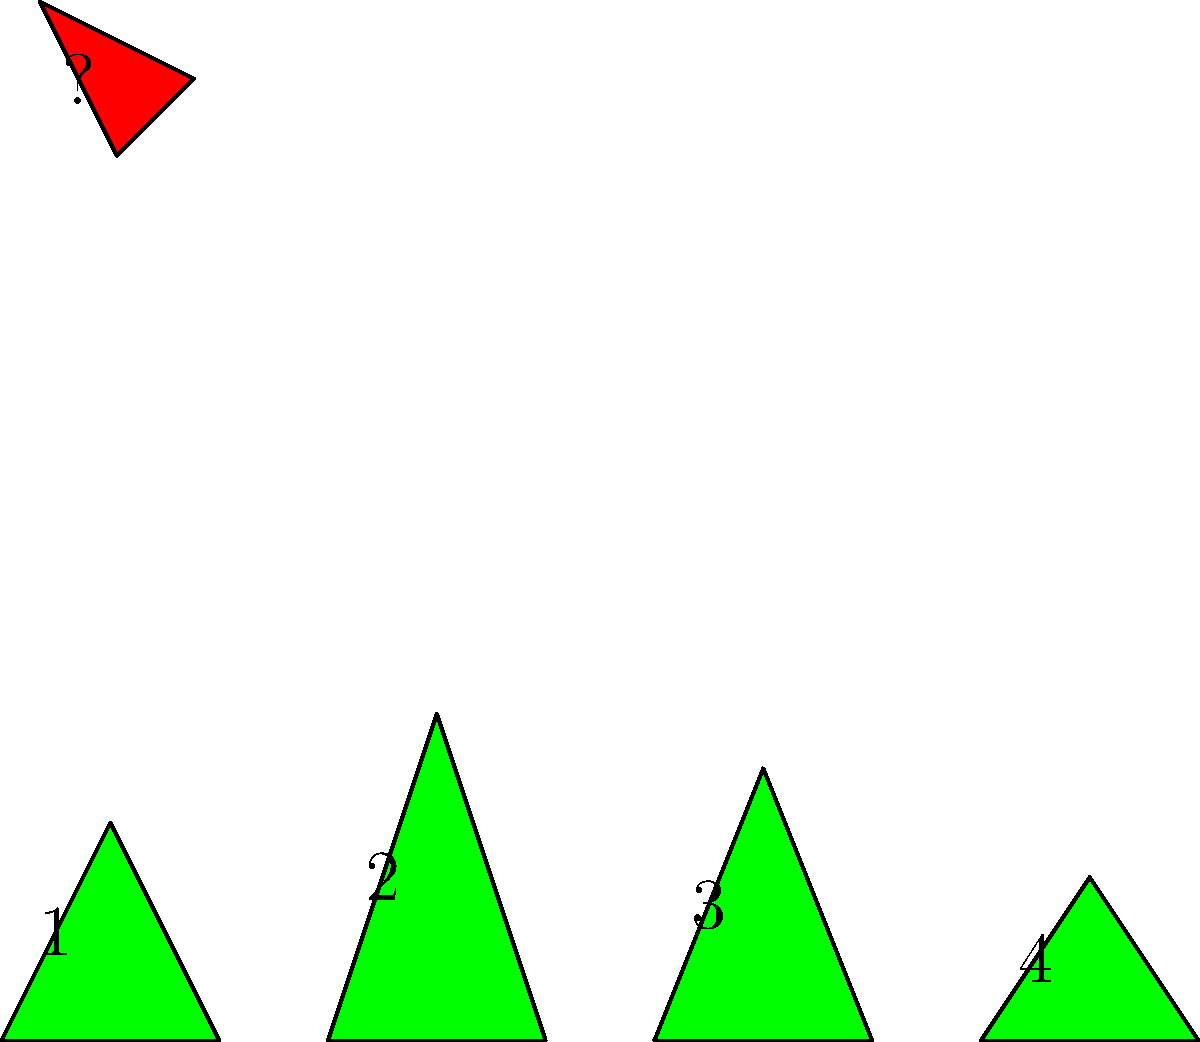In a beauty pageant, four contestants are wearing different evening gowns represented by the green triangles labeled 1 to 4. The red triangle represents a rotated and scaled version of one of these gowns. Which contestant's gown matches the red triangle when rotated and scaled appropriately? To solve this problem, we need to mentally rotate and scale each of the green triangles to see which one matches the red triangle. Let's analyze each gown:

1. Observe the shape of each green triangle (gown):
   - Gown 1: Roughly equilateral
   - Gown 2: Tall and narrow
   - Gown 3: Medium height, wider at the base
   - Gown 4: Short and wide

2. Now, look at the red triangle:
   - It's tall and narrow, similar to Gown 2

3. Mentally rotate Gown 2 by approximately 45 degrees clockwise:
   - The shape after rotation closely resembles the red triangle

4. Consider the scale:
   - The red triangle is smaller than the green triangles
   - Gown 2, when scaled down, would match the red triangle's size

5. Compare the proportions:
   - The ratio of height to width in the red triangle is similar to that of Gown 2

6. Eliminate other options:
   - Gowns 1, 3, and 4 have different proportions that wouldn't match the red triangle even when rotated and scaled

Therefore, the gown that matches the red triangle when rotated and scaled is Gown 2.
Answer: 2 